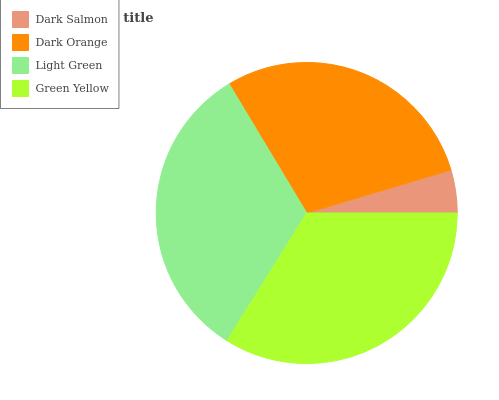Is Dark Salmon the minimum?
Answer yes or no. Yes. Is Green Yellow the maximum?
Answer yes or no. Yes. Is Dark Orange the minimum?
Answer yes or no. No. Is Dark Orange the maximum?
Answer yes or no. No. Is Dark Orange greater than Dark Salmon?
Answer yes or no. Yes. Is Dark Salmon less than Dark Orange?
Answer yes or no. Yes. Is Dark Salmon greater than Dark Orange?
Answer yes or no. No. Is Dark Orange less than Dark Salmon?
Answer yes or no. No. Is Light Green the high median?
Answer yes or no. Yes. Is Dark Orange the low median?
Answer yes or no. Yes. Is Dark Orange the high median?
Answer yes or no. No. Is Light Green the low median?
Answer yes or no. No. 